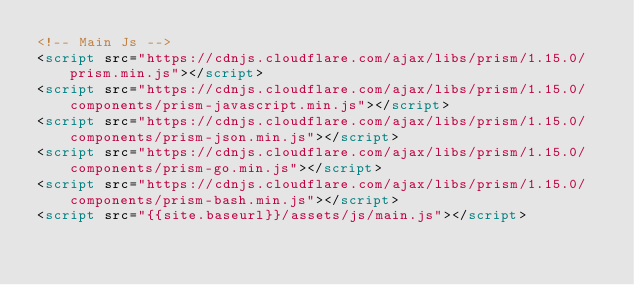<code> <loc_0><loc_0><loc_500><loc_500><_HTML_><!-- Main Js -->
<script src="https://cdnjs.cloudflare.com/ajax/libs/prism/1.15.0/prism.min.js"></script>
<script src="https://cdnjs.cloudflare.com/ajax/libs/prism/1.15.0/components/prism-javascript.min.js"></script>
<script src="https://cdnjs.cloudflare.com/ajax/libs/prism/1.15.0/components/prism-json.min.js"></script>
<script src="https://cdnjs.cloudflare.com/ajax/libs/prism/1.15.0/components/prism-go.min.js"></script>
<script src="https://cdnjs.cloudflare.com/ajax/libs/prism/1.15.0/components/prism-bash.min.js"></script>
<script src="{{site.baseurl}}/assets/js/main.js"></script>
</code> 